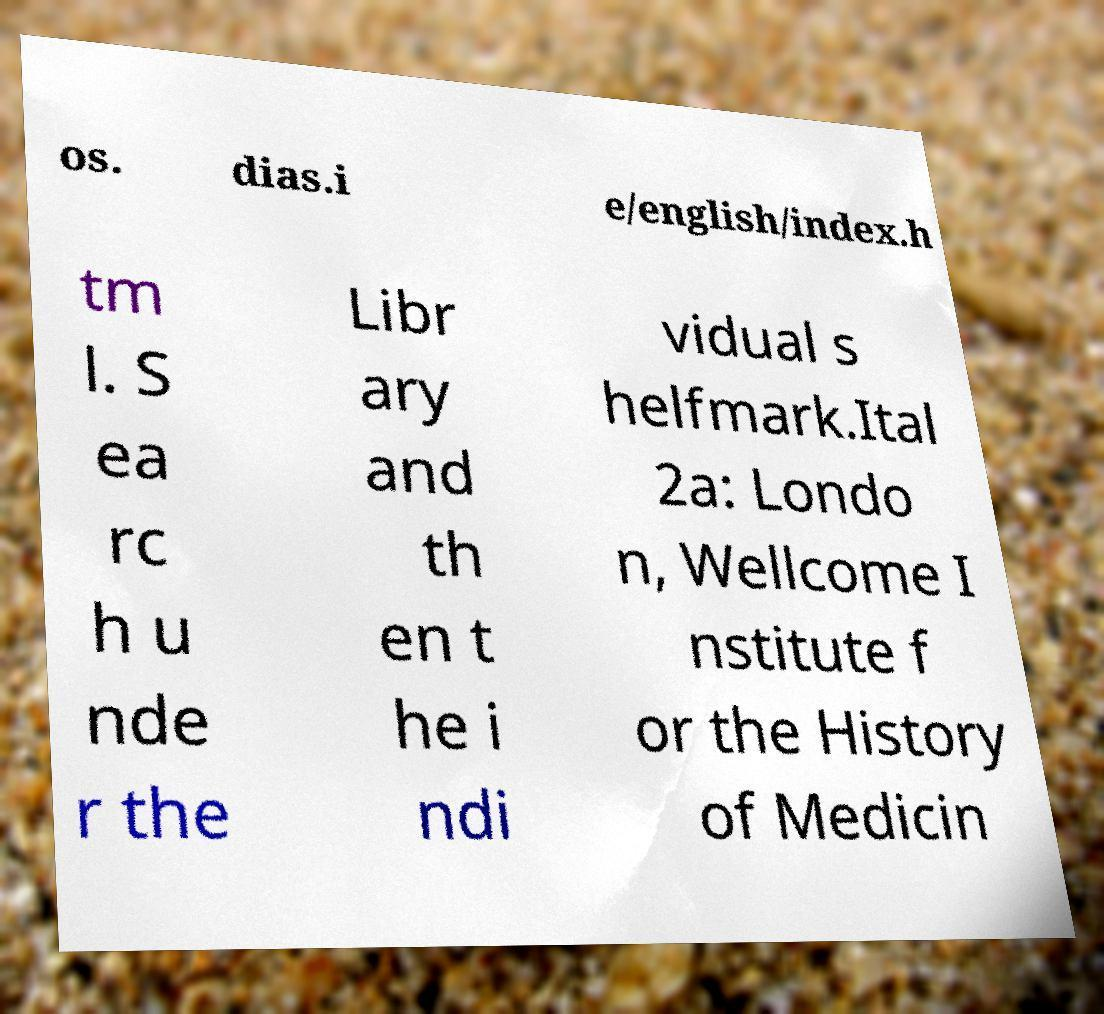Please read and relay the text visible in this image. What does it say? os. dias.i e/english/index.h tm l. S ea rc h u nde r the Libr ary and th en t he i ndi vidual s helfmark.Ital 2a: Londo n, Wellcome I nstitute f or the History of Medicin 